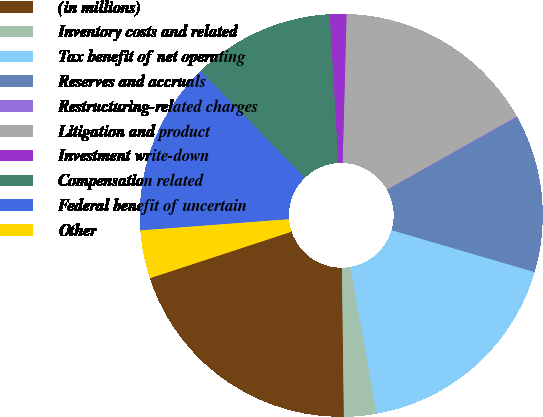Convert chart to OTSL. <chart><loc_0><loc_0><loc_500><loc_500><pie_chart><fcel>(in millions)<fcel>Inventory costs and related<fcel>Tax benefit of net operating<fcel>Reserves and accruals<fcel>Restructuring-related charges<fcel>Litigation and product<fcel>Investment write-down<fcel>Compensation related<fcel>Federal benefit of uncertain<fcel>Other<nl><fcel>20.16%<fcel>2.6%<fcel>17.65%<fcel>12.63%<fcel>0.09%<fcel>16.4%<fcel>1.34%<fcel>11.38%<fcel>13.89%<fcel>3.85%<nl></chart> 